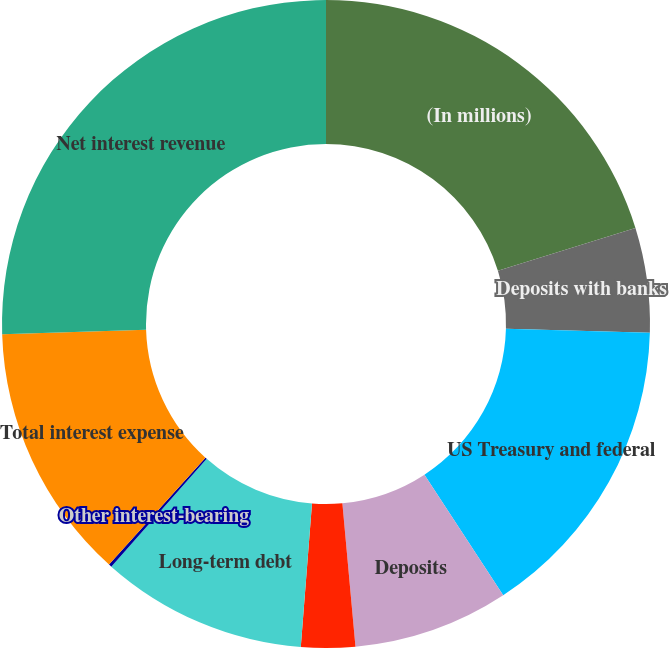Convert chart. <chart><loc_0><loc_0><loc_500><loc_500><pie_chart><fcel>(In millions)<fcel>Deposits with banks<fcel>US Treasury and federal<fcel>Deposits<fcel>Short-term borrowings (1)<fcel>Long-term debt<fcel>Other interest-bearing<fcel>Total interest expense<fcel>Net interest revenue<nl><fcel>20.21%<fcel>5.22%<fcel>15.36%<fcel>7.76%<fcel>2.69%<fcel>10.29%<fcel>0.15%<fcel>12.82%<fcel>25.5%<nl></chart> 